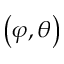<formula> <loc_0><loc_0><loc_500><loc_500>\left ( \varphi , \theta \right )</formula> 